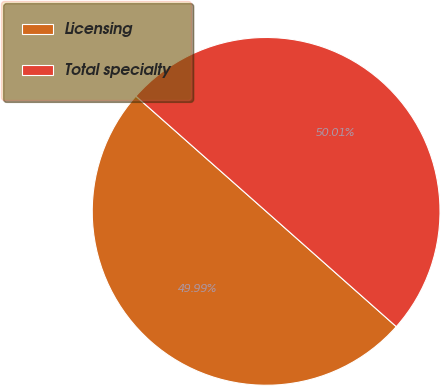Convert chart. <chart><loc_0><loc_0><loc_500><loc_500><pie_chart><fcel>Licensing<fcel>Total specialty<nl><fcel>49.99%<fcel>50.01%<nl></chart> 